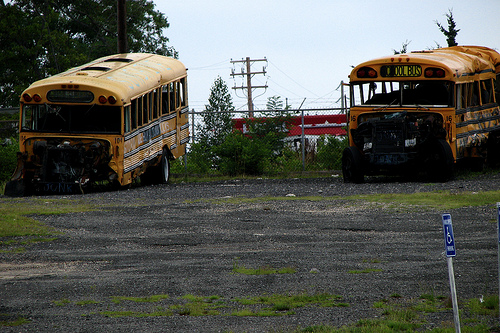Is the vehicle on the road yellow and old? Yes, the bus shown on the road has a yellow exterior and shows signs of significant wear and damage, indicating it is old. 